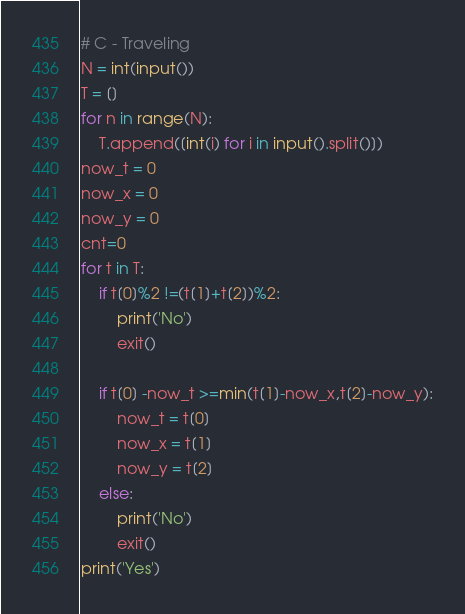Convert code to text. <code><loc_0><loc_0><loc_500><loc_500><_Python_># C - Traveling
N = int(input())
T = []
for n in range(N):
    T.append([int(i) for i in input().split()])
now_t = 0
now_x = 0
now_y = 0
cnt=0
for t in T:
    if t[0]%2 !=(t[1]+t[2])%2:
        print('No')
        exit()
        
    if t[0] -now_t >=min(t[1]-now_x,t[2]-now_y):
        now_t = t[0]
        now_x = t[1]
        now_y = t[2]
    else:
        print('No')
        exit()
print('Yes')</code> 